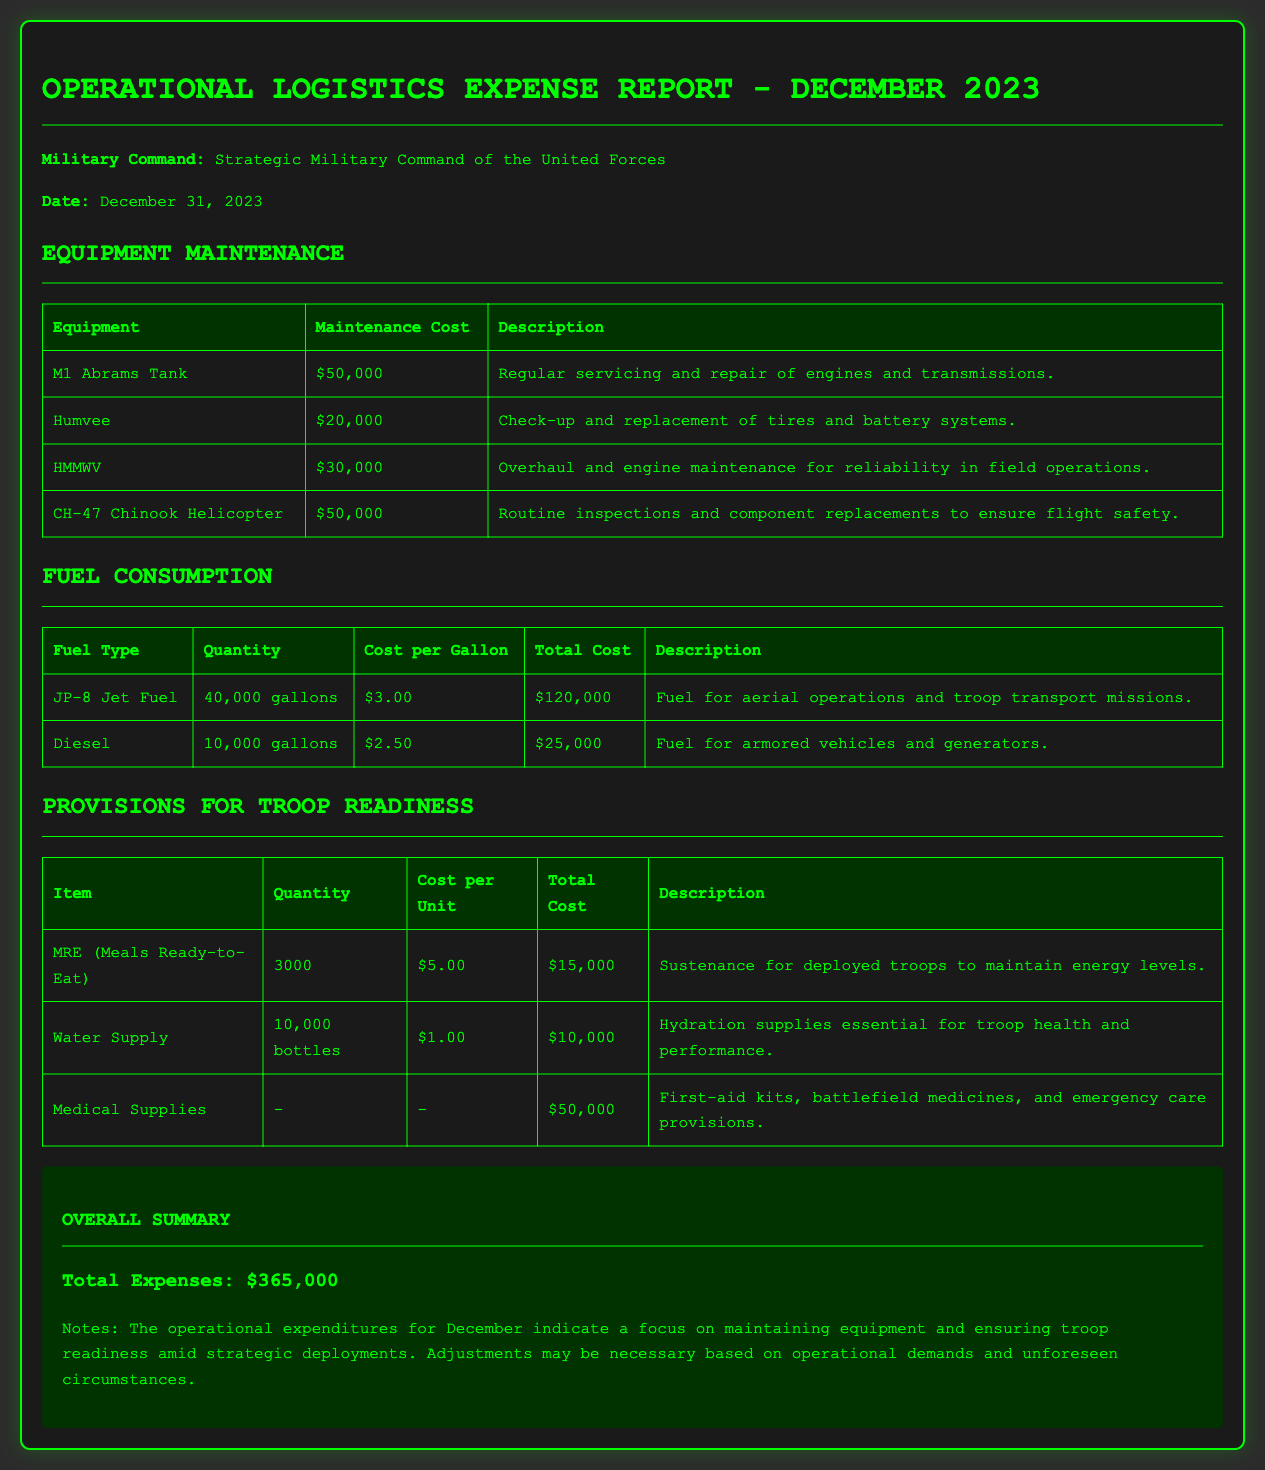What is the total cost for M1 Abrams Tank maintenance? The maintenance cost for M1 Abrams Tank is stated directly in the document as $50,000.
Answer: $50,000 How much JP-8 Jet Fuel was consumed? The document specifies that 40,000 gallons of JP-8 Jet Fuel were used.
Answer: 40,000 gallons What is the total expense for fuel consumption? The document outlines total fuel costs of $120,000 for JP-8 Jet Fuel and $25,000 for Diesel, giving a combined total of $145,000.
Answer: $145,000 What are the total expenses reported for December 2023? The final summary section indicates that the total expenses for December are $365,000.
Answer: $365,000 How many MREs were allocated for troop readiness? The report states that 3,000 MREs were provided for troops.
Answer: 3,000 What percentage of the total expenses is dedicated to medical supplies? The document indicates that medical supplies cost $50,000, which equals approximately 13.7% of the total expenses.
Answer: 13.7% What is the maintenance cost for the CH-47 Chinook Helicopter? The maintenance expense listed for CH-47 Chinook Helicopter is $50,000.
Answer: $50,000 What quantity of water bottles was budgeted? The report shows a provision of 10,000 bottles for water supply.
Answer: 10,000 bottles How much did the Humvee maintenance cost? The document specifies that the Humvee maintenance cost is $20,000.
Answer: $20,000 What type of fuel is primarily used for aerial operations? The document indicates that JP-8 Jet Fuel is used for aerial operations.
Answer: JP-8 Jet Fuel 